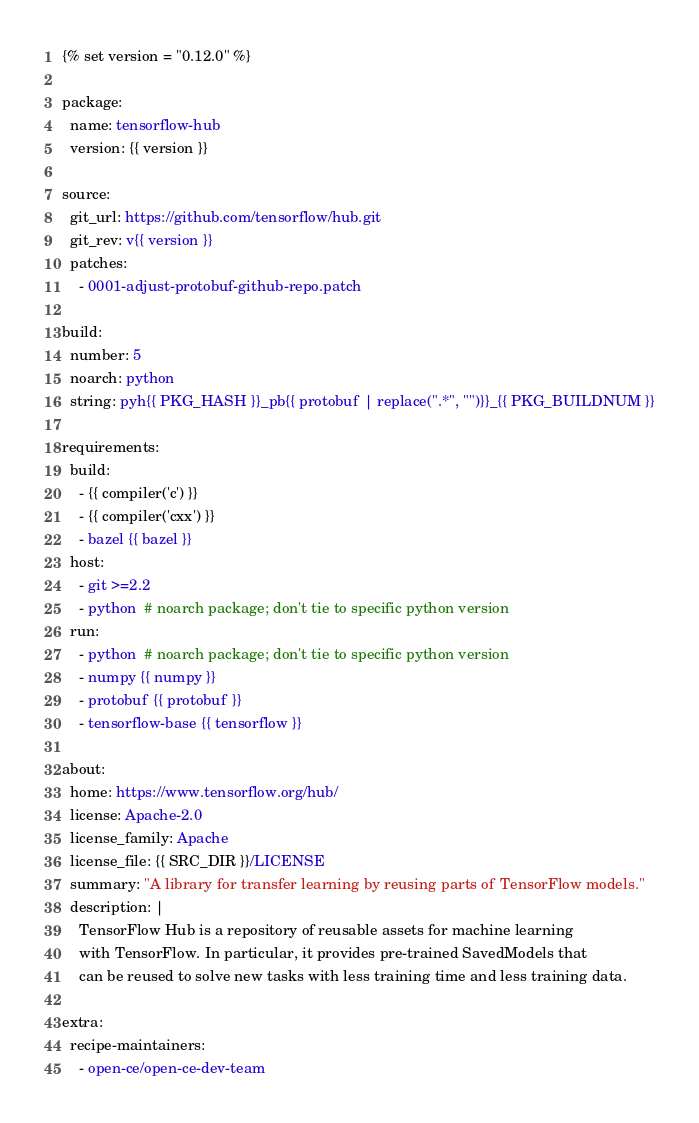<code> <loc_0><loc_0><loc_500><loc_500><_YAML_>{% set version = "0.12.0" %}

package:
  name: tensorflow-hub
  version: {{ version }}

source:
  git_url: https://github.com/tensorflow/hub.git
  git_rev: v{{ version }}
  patches:
    - 0001-adjust-protobuf-github-repo.patch

build:
  number: 5
  noarch: python
  string: pyh{{ PKG_HASH }}_pb{{ protobuf | replace(".*", "")}}_{{ PKG_BUILDNUM }}
  
requirements:
  build:
    - {{ compiler('c') }}
    - {{ compiler('cxx') }}
    - bazel {{ bazel }}
  host:
    - git >=2.2
    - python  # noarch package; don't tie to specific python version
  run:
    - python  # noarch package; don't tie to specific python version
    - numpy {{ numpy }}
    - protobuf {{ protobuf }}
    - tensorflow-base {{ tensorflow }}

about:
  home: https://www.tensorflow.org/hub/
  license: Apache-2.0
  license_family: Apache
  license_file: {{ SRC_DIR }}/LICENSE
  summary: "A library for transfer learning by reusing parts of TensorFlow models."
  description: |
    TensorFlow Hub is a repository of reusable assets for machine learning 
    with TensorFlow. In particular, it provides pre-trained SavedModels that 
    can be reused to solve new tasks with less training time and less training data.

extra:
  recipe-maintainers:
    - open-ce/open-ce-dev-team
</code> 